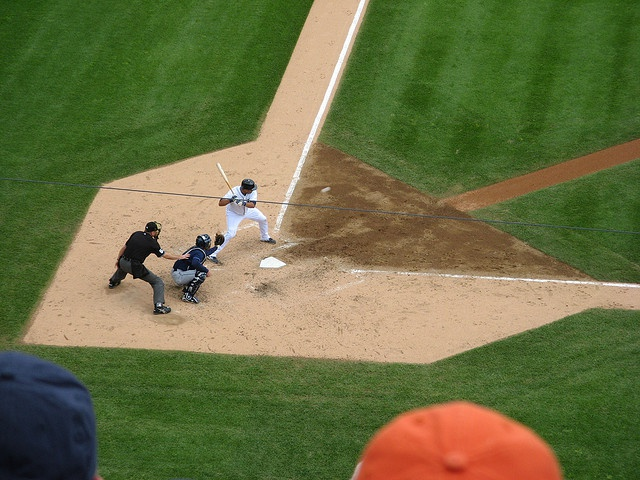Describe the objects in this image and their specific colors. I can see people in darkgreen, red, salmon, brown, and olive tones, people in darkgreen, black, navy, darkblue, and blue tones, people in darkgreen, black, gray, and maroon tones, people in darkgreen, lavender, darkgray, and tan tones, and people in darkgreen, black, gray, navy, and darkgray tones in this image. 